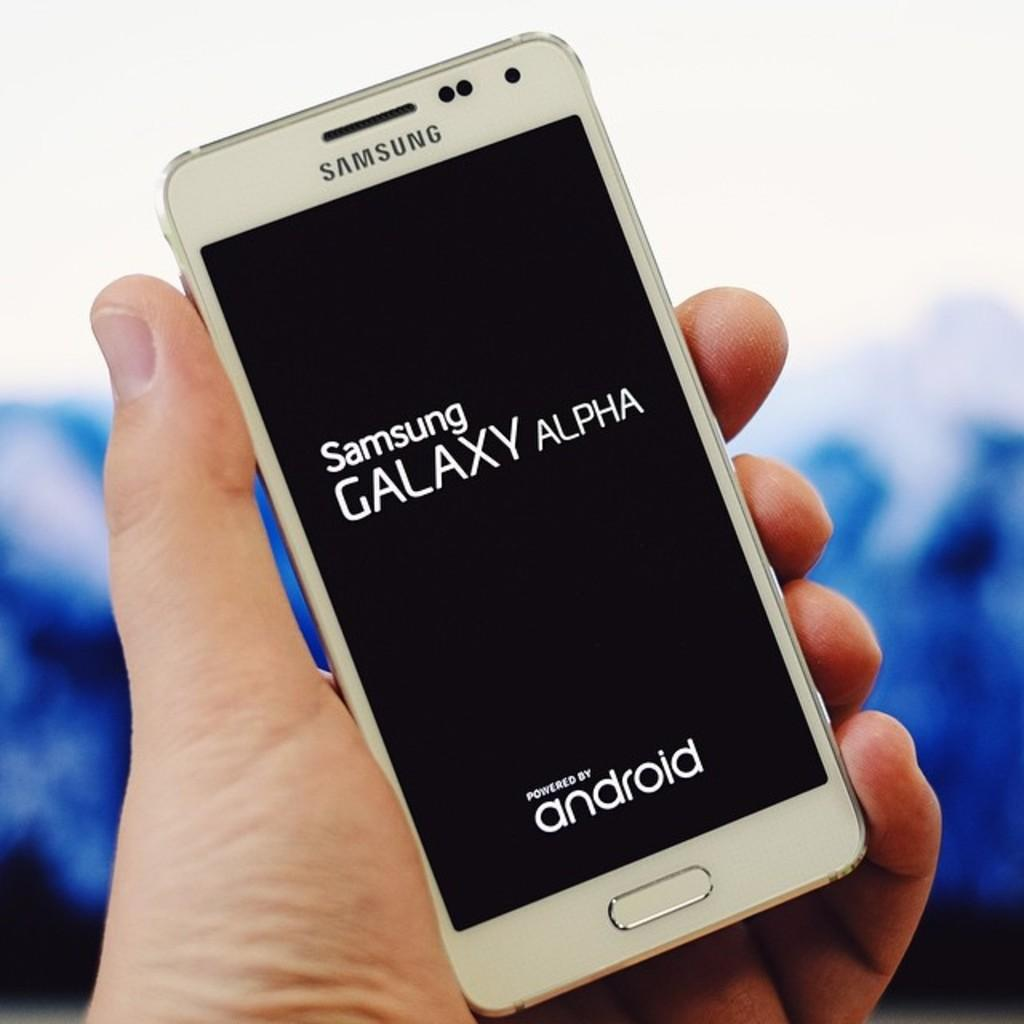<image>
Describe the image concisely. A Samsung Galaxy Alpha phone is being held in someone's hand. 